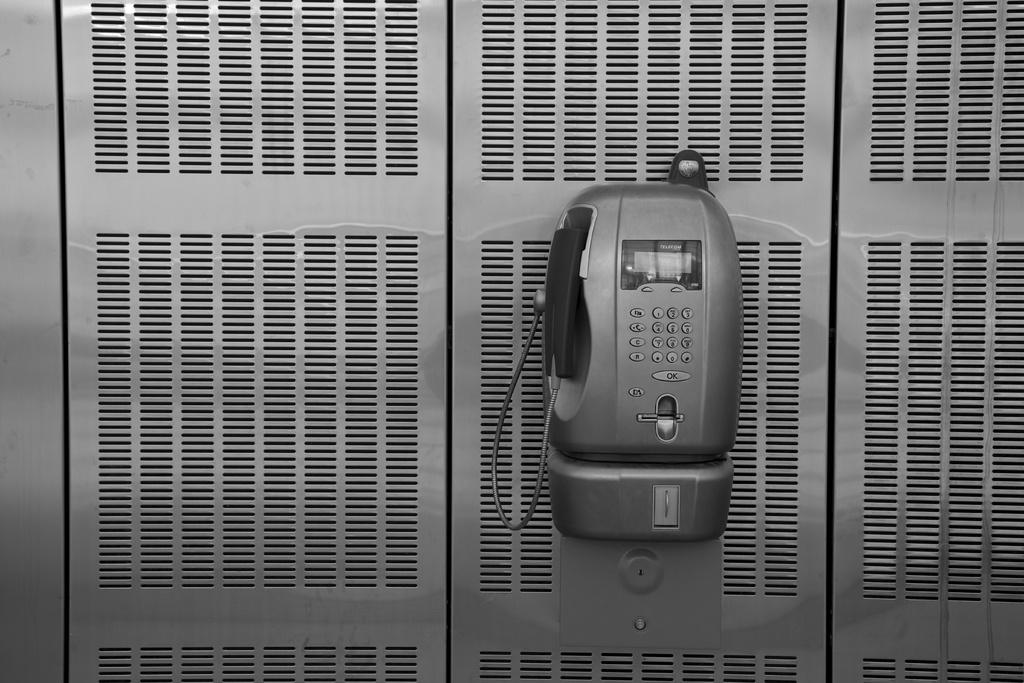What object is the main subject of the image? There is a telephone in the image. What is the telephone placed on? The telephone is on a steel object. How can the user interact with the telephone? The telephone has buttons. What is connected to the left side of the telephone? There is a cable on the left side of the telephone. What type of advice can be heard coming from the telephone in the image? There is no indication in the image that the telephone is providing any advice, as it is not in use. What brand of toothpaste is advertised on the telephone in the image? There is no toothpaste or advertisement present on the telephone in the image. 